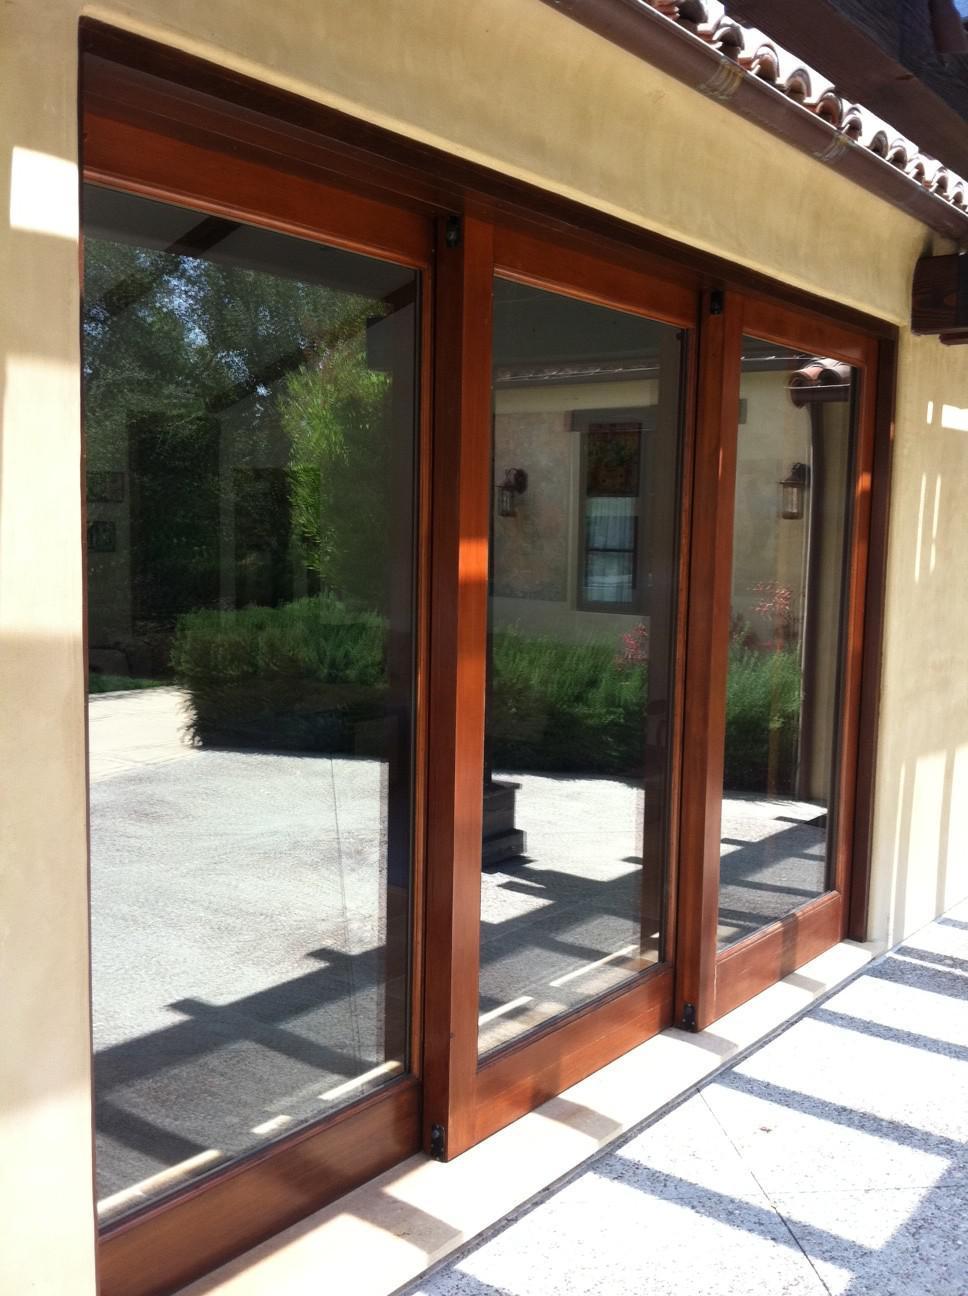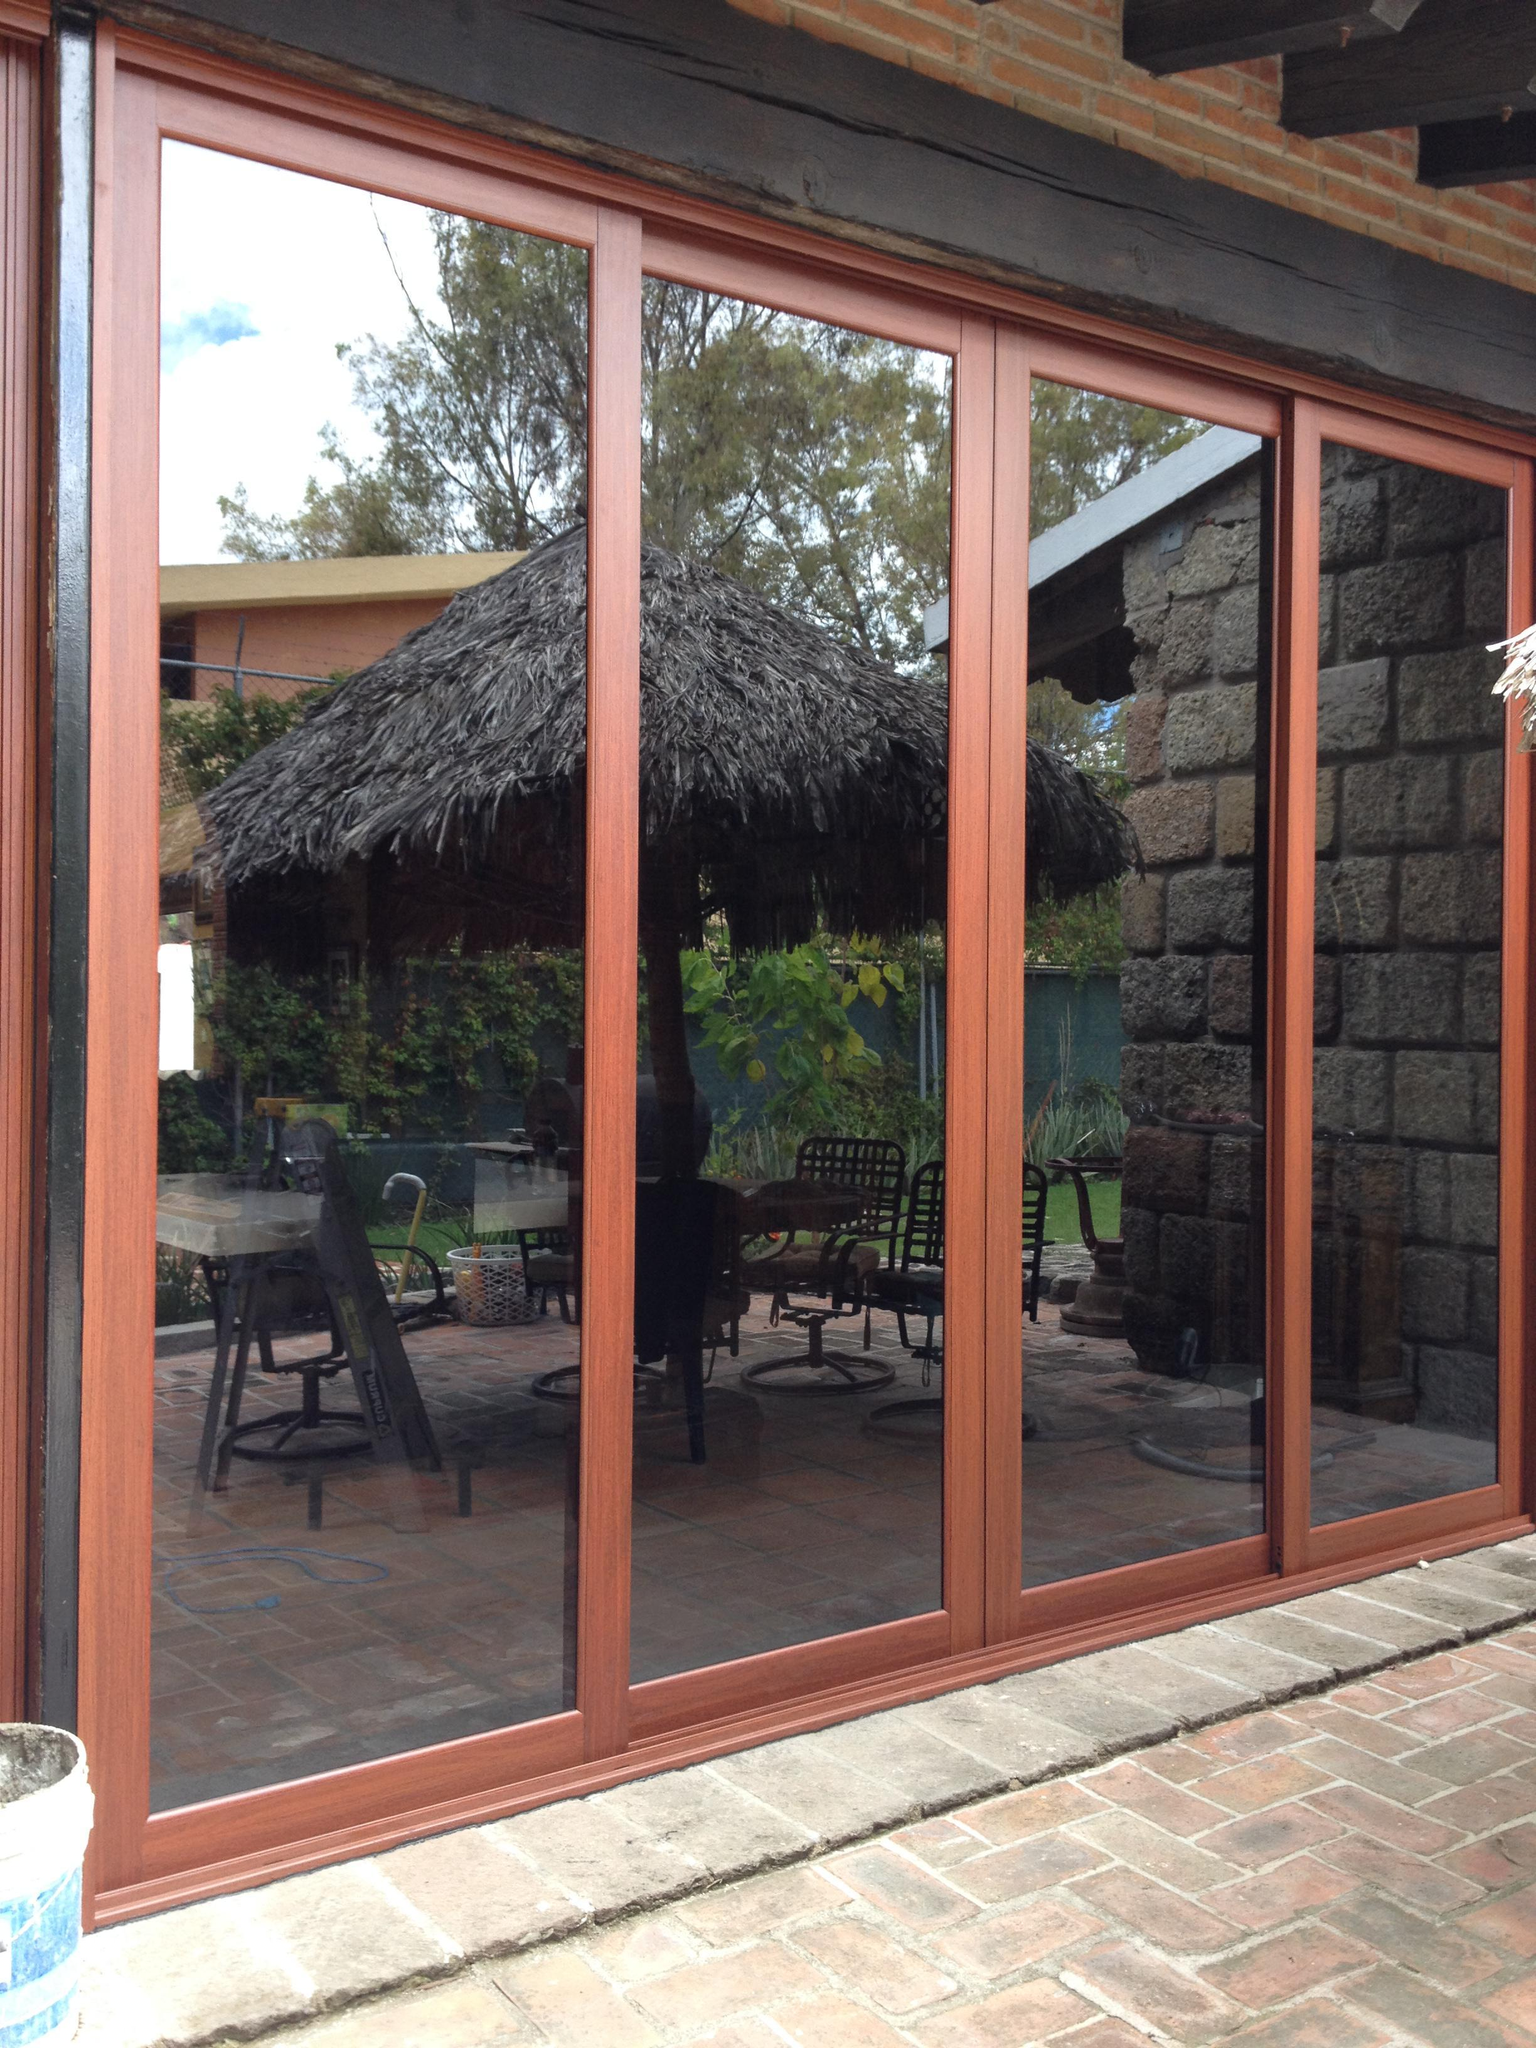The first image is the image on the left, the second image is the image on the right. Examine the images to the left and right. Is the description "The image on the left has a white wood-trimmed glass door." accurate? Answer yes or no. No. The first image is the image on the left, the second image is the image on the right. Considering the images on both sides, is "All the doors are closed." valid? Answer yes or no. Yes. 